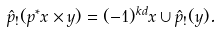Convert formula to latex. <formula><loc_0><loc_0><loc_500><loc_500>\hat { p } _ { ! } ( p ^ { * } x \times y ) = ( - 1 ) ^ { k d } x \cup \hat { p } _ { ! } ( y ) .</formula> 